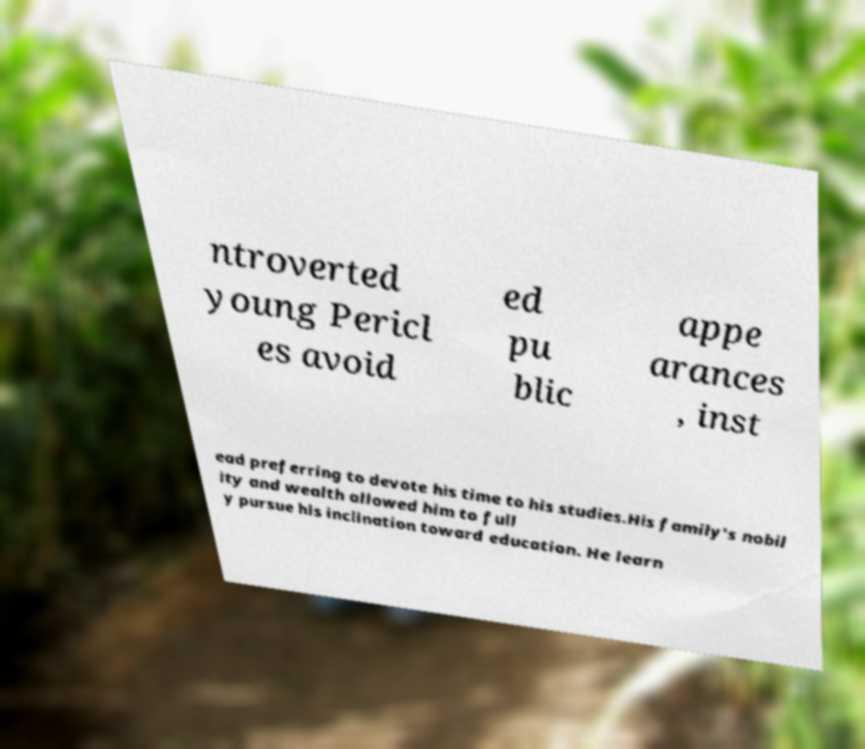Can you read and provide the text displayed in the image?This photo seems to have some interesting text. Can you extract and type it out for me? ntroverted young Pericl es avoid ed pu blic appe arances , inst ead preferring to devote his time to his studies.His family's nobil ity and wealth allowed him to full y pursue his inclination toward education. He learn 